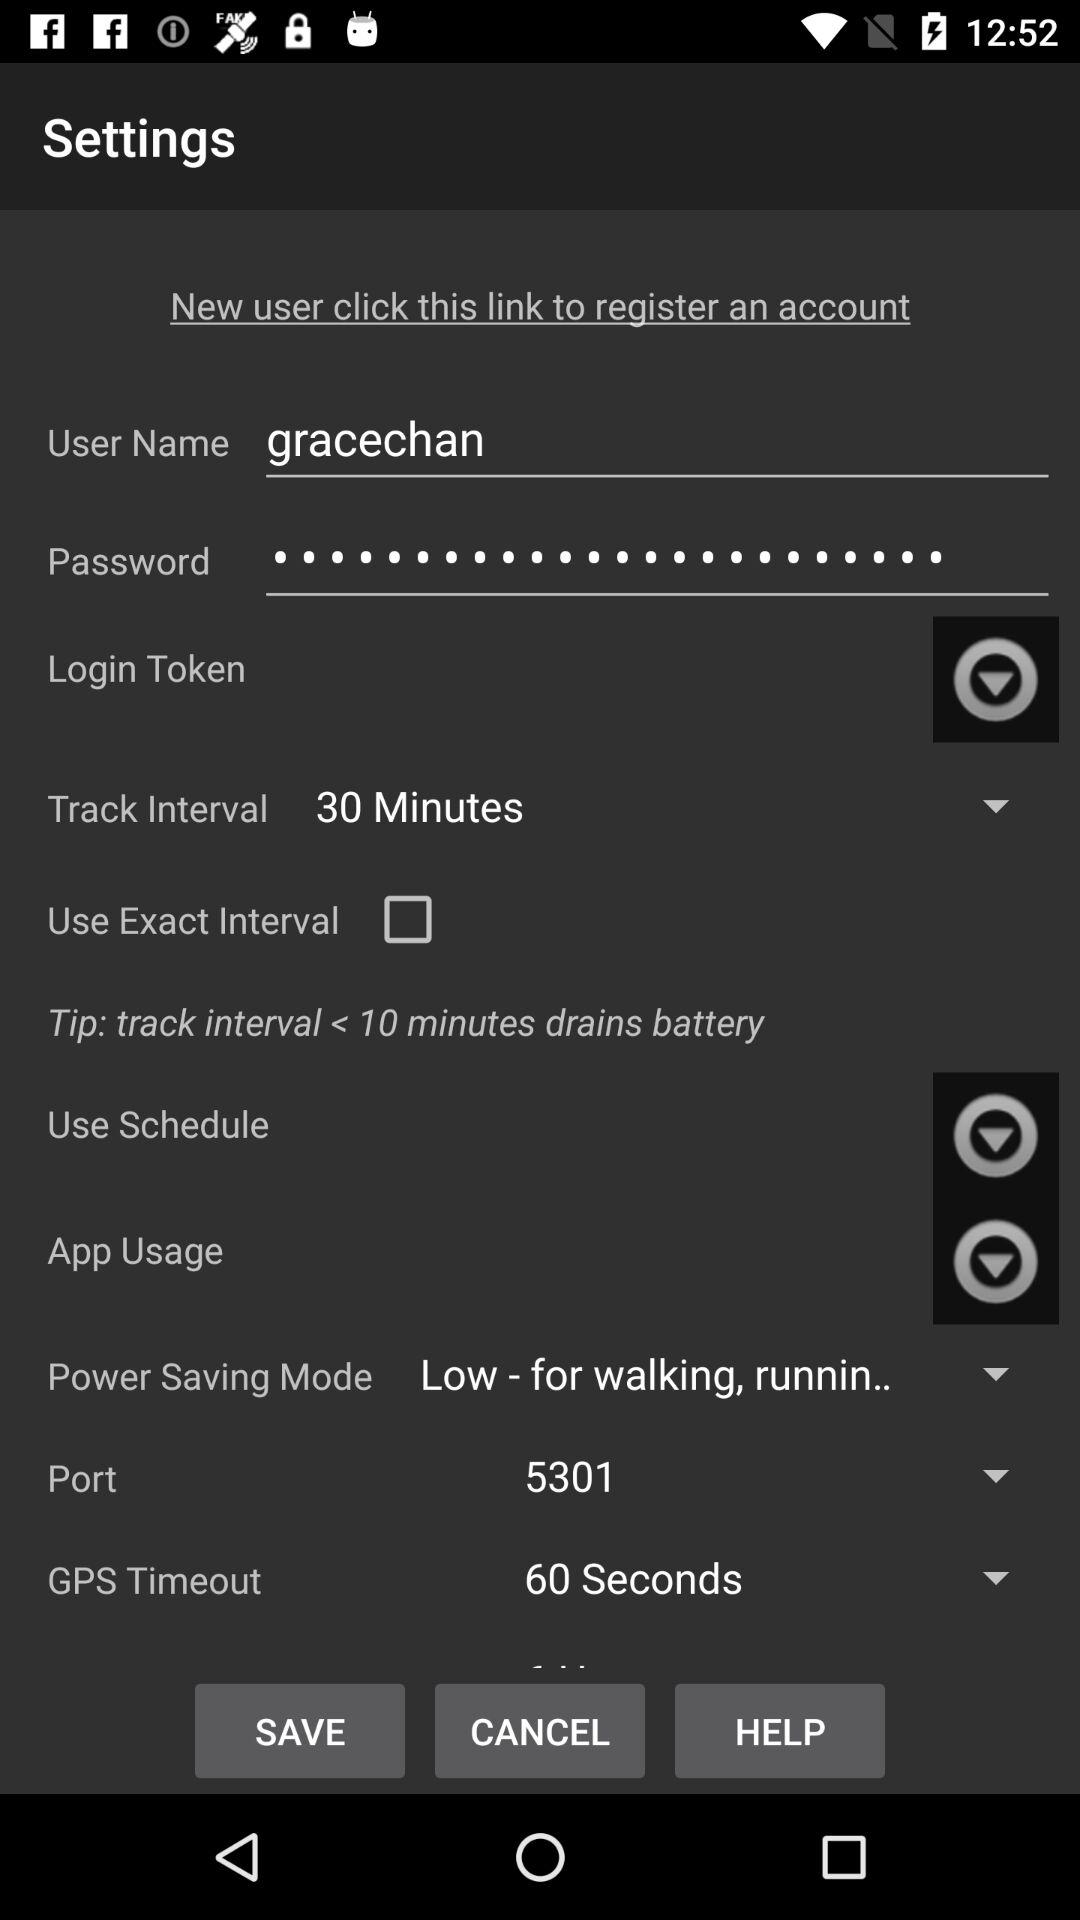What is the port number? The port number is 54301. 